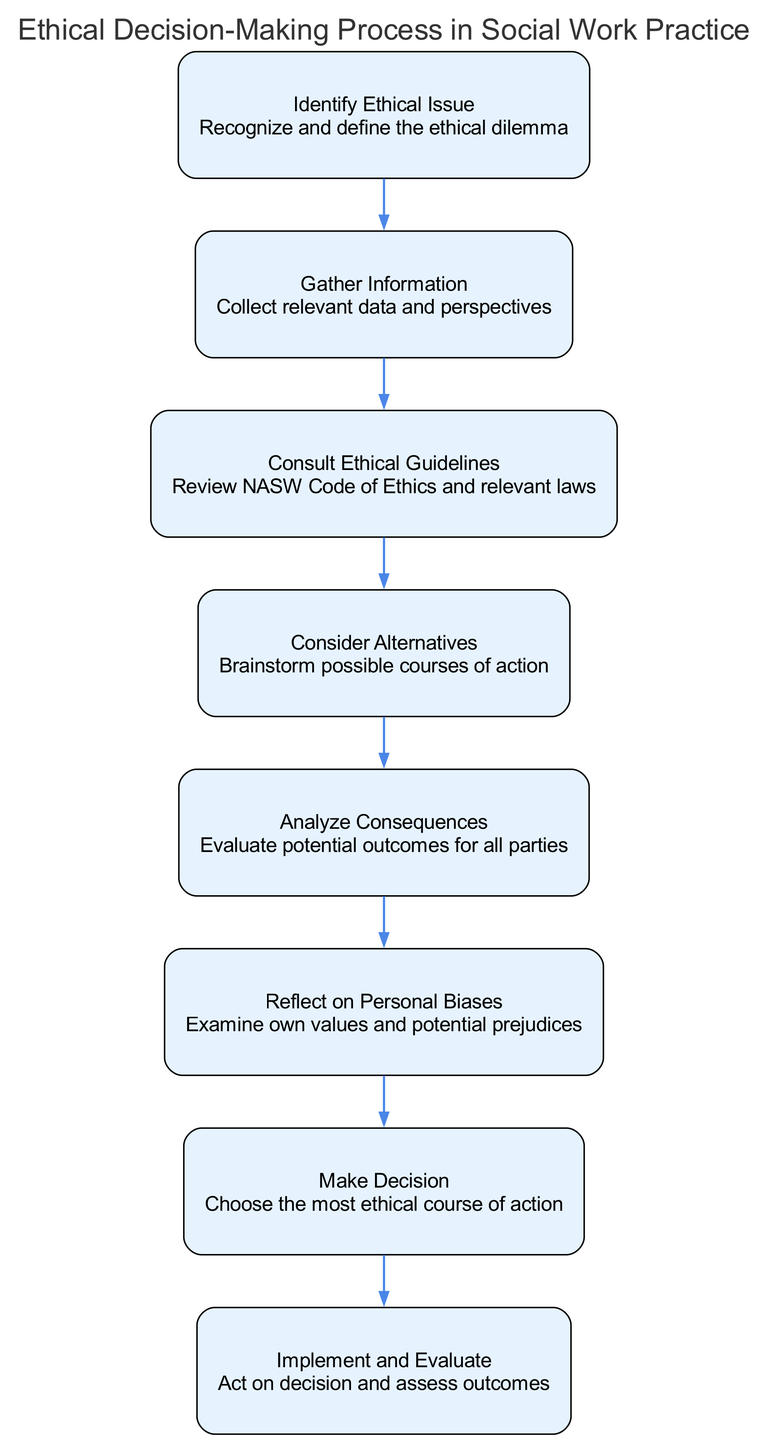What is the first step in the ethical decision-making process? The first step in the process is identified as "Identify Ethical Issue," which is represented at the top of the diagram.
Answer: Identify Ethical Issue How many elements are in the diagram? The diagram contains a total of eight elements that represent different steps in the ethical decision-making process.
Answer: Eight What step follows "Gather Information"? The step that follows "Gather Information" is "Consult Ethical Guidelines," according to the directional flow indicated in the diagram.
Answer: Consult Ethical Guidelines What does the "Analyze Consequences" step focus on? The "Analyze Consequences" step focuses on evaluating the potential outcomes for all parties involved in the ethical dilemma.
Answer: Evaluating potential outcomes Which two steps are directly connected without any intervening steps? The direct connections without any intervening steps are from "Make Decision" to "Implement and Evaluate." This indicates a sequence in the decision-making process.
Answer: Make Decision to Implement and Evaluate How does personal bias influence the decision-making process? Personal bias is examined in the "Reflect on Personal Biases" step, which leads to "Make Decision." Recognizing biases affects the course of action chosen during the decision-making process.
Answer: Examining own values and potential prejudices What is the final outcome of the ethical decision-making process? The final outcome of the process is denoted as "Implement and Evaluate," which concludes the sequence of decision-making steps.
Answer: Implement and Evaluate What do the arrows in the diagram signify? The arrows in the diagram signify the direction of flow between different steps in the ethical decision-making process, indicating the sequence of actions taken.
Answer: Direction of flow How does the "Consider Alternatives" step relate to "Analyze Consequences"? The "Consider Alternatives" step is connected to "Analyze Consequences" as it is followed by evaluating the outcomes of the various alternatives generated in the previous step.
Answer: Analyzing potential outcomes for alternatives 